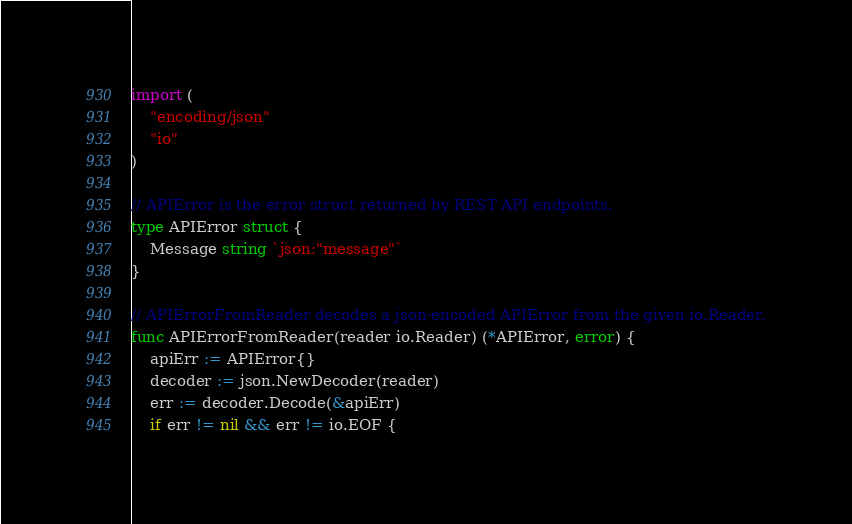Convert code to text. <code><loc_0><loc_0><loc_500><loc_500><_Go_>import (
	"encoding/json"
	"io"
)

// APIError is the error struct returned by REST API endpoints.
type APIError struct {
	Message string `json:"message"`
}

// APIErrorFromReader decodes a json-encoded APIError from the given io.Reader.
func APIErrorFromReader(reader io.Reader) (*APIError, error) {
	apiErr := APIError{}
	decoder := json.NewDecoder(reader)
	err := decoder.Decode(&apiErr)
	if err != nil && err != io.EOF {</code> 